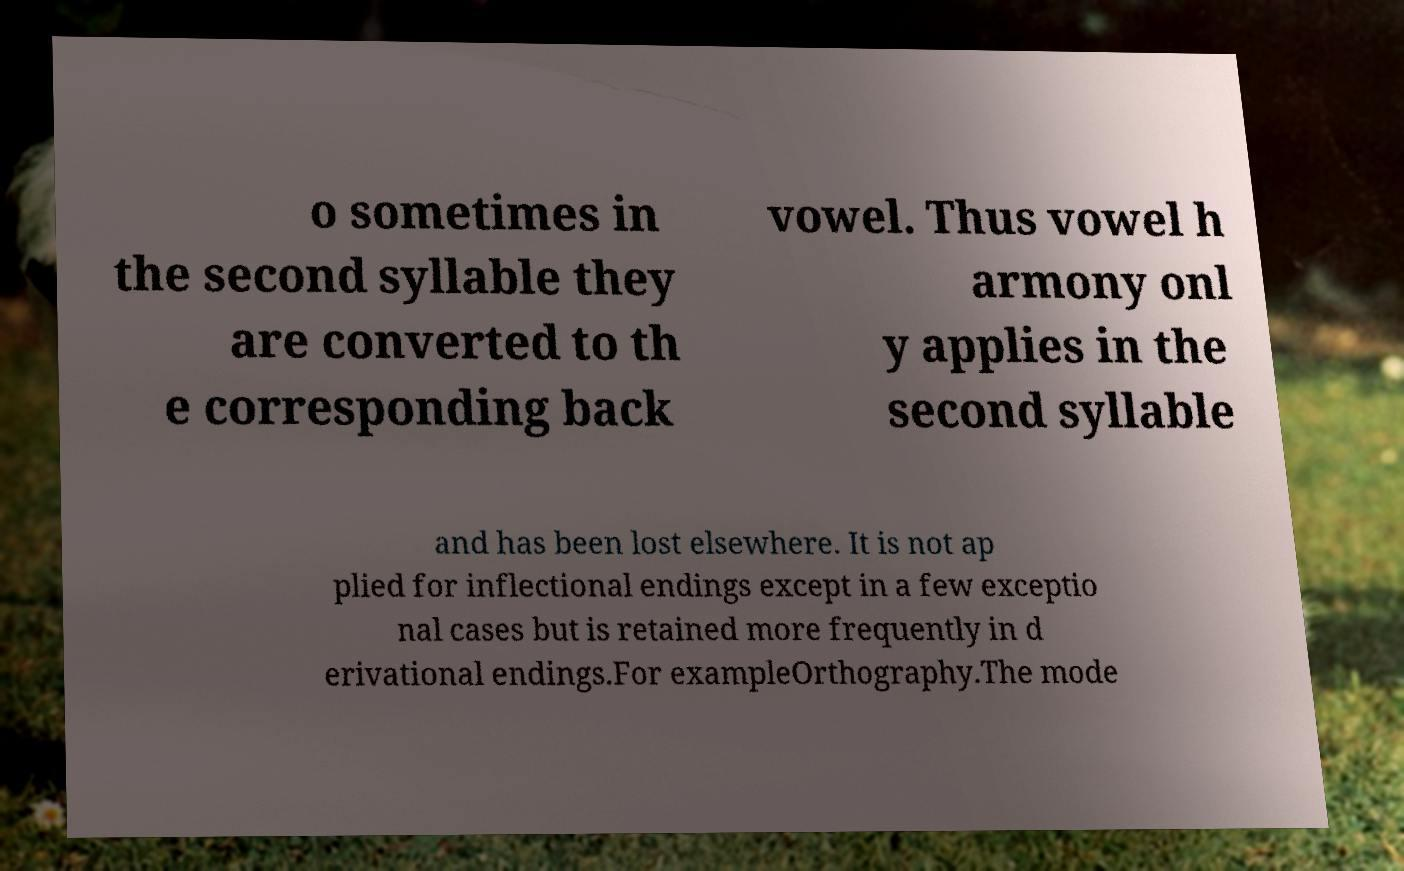There's text embedded in this image that I need extracted. Can you transcribe it verbatim? o sometimes in the second syllable they are converted to th e corresponding back vowel. Thus vowel h armony onl y applies in the second syllable and has been lost elsewhere. It is not ap plied for inflectional endings except in a few exceptio nal cases but is retained more frequently in d erivational endings.For exampleOrthography.The mode 